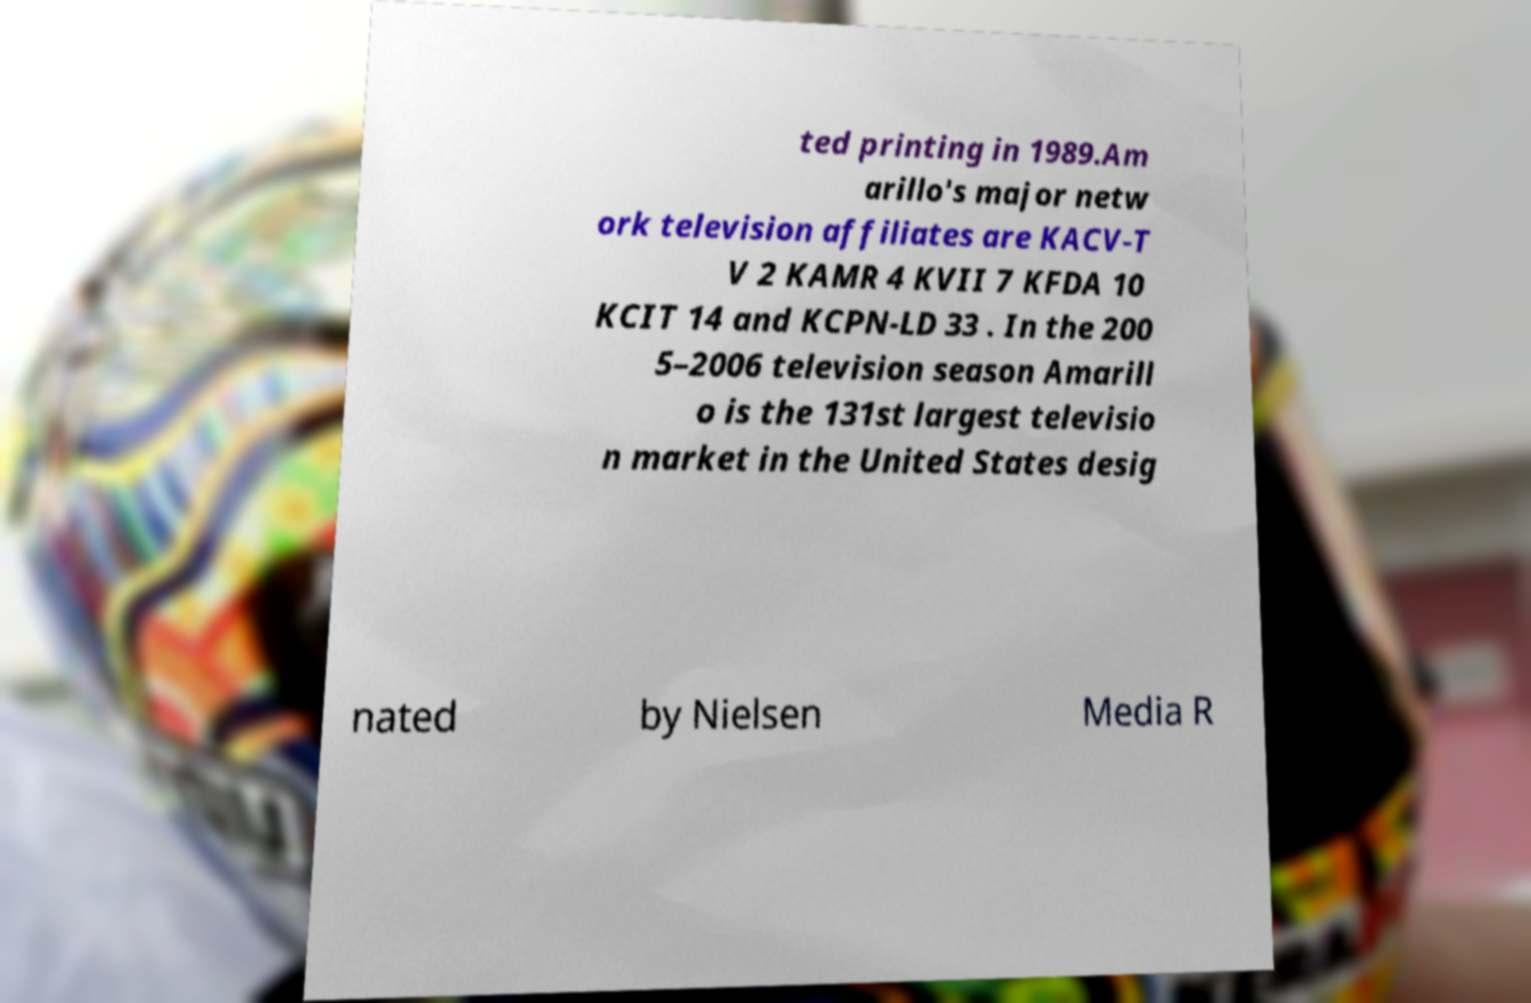Could you extract and type out the text from this image? ted printing in 1989.Am arillo's major netw ork television affiliates are KACV-T V 2 KAMR 4 KVII 7 KFDA 10 KCIT 14 and KCPN-LD 33 . In the 200 5–2006 television season Amarill o is the 131st largest televisio n market in the United States desig nated by Nielsen Media R 